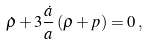<formula> <loc_0><loc_0><loc_500><loc_500>\dot { \rho } + 3 \frac { \dot { a } } { a } \left ( \rho + p \right ) = 0 \, ,</formula> 